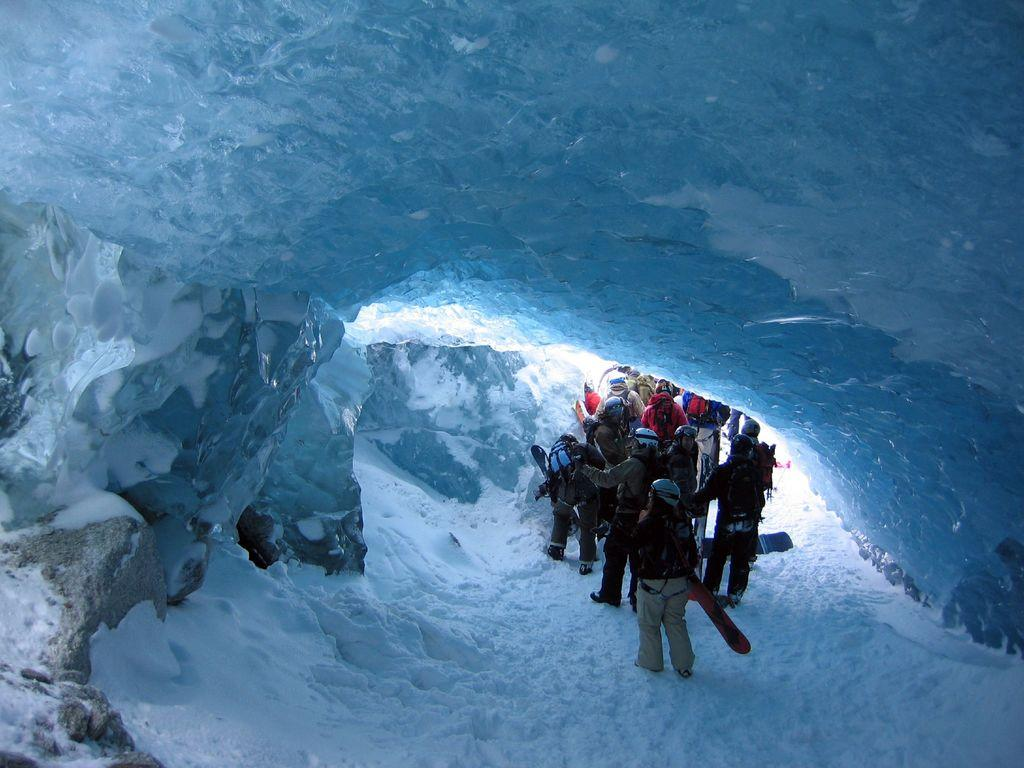What type of structure is present in the image? There is a snow cave in the image. What are the people doing inside the snow cave? The people are walking inside the snow cave. What type of war equipment can be seen inside the snow cave? There is no war equipment present inside the snow cave; it only contains people walking. Where is the lunchroom located in the image? There is no lunchroom present in the image; it features a snow cave with people walking inside. 